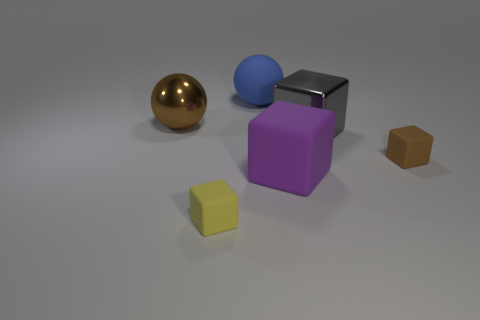Which objects in the scene could fit inside the blue sphere if it were hollow? If the blue sphere were hollow, both the yellow and the small brown cube could potentially fit inside it due to their smaller sizes. 